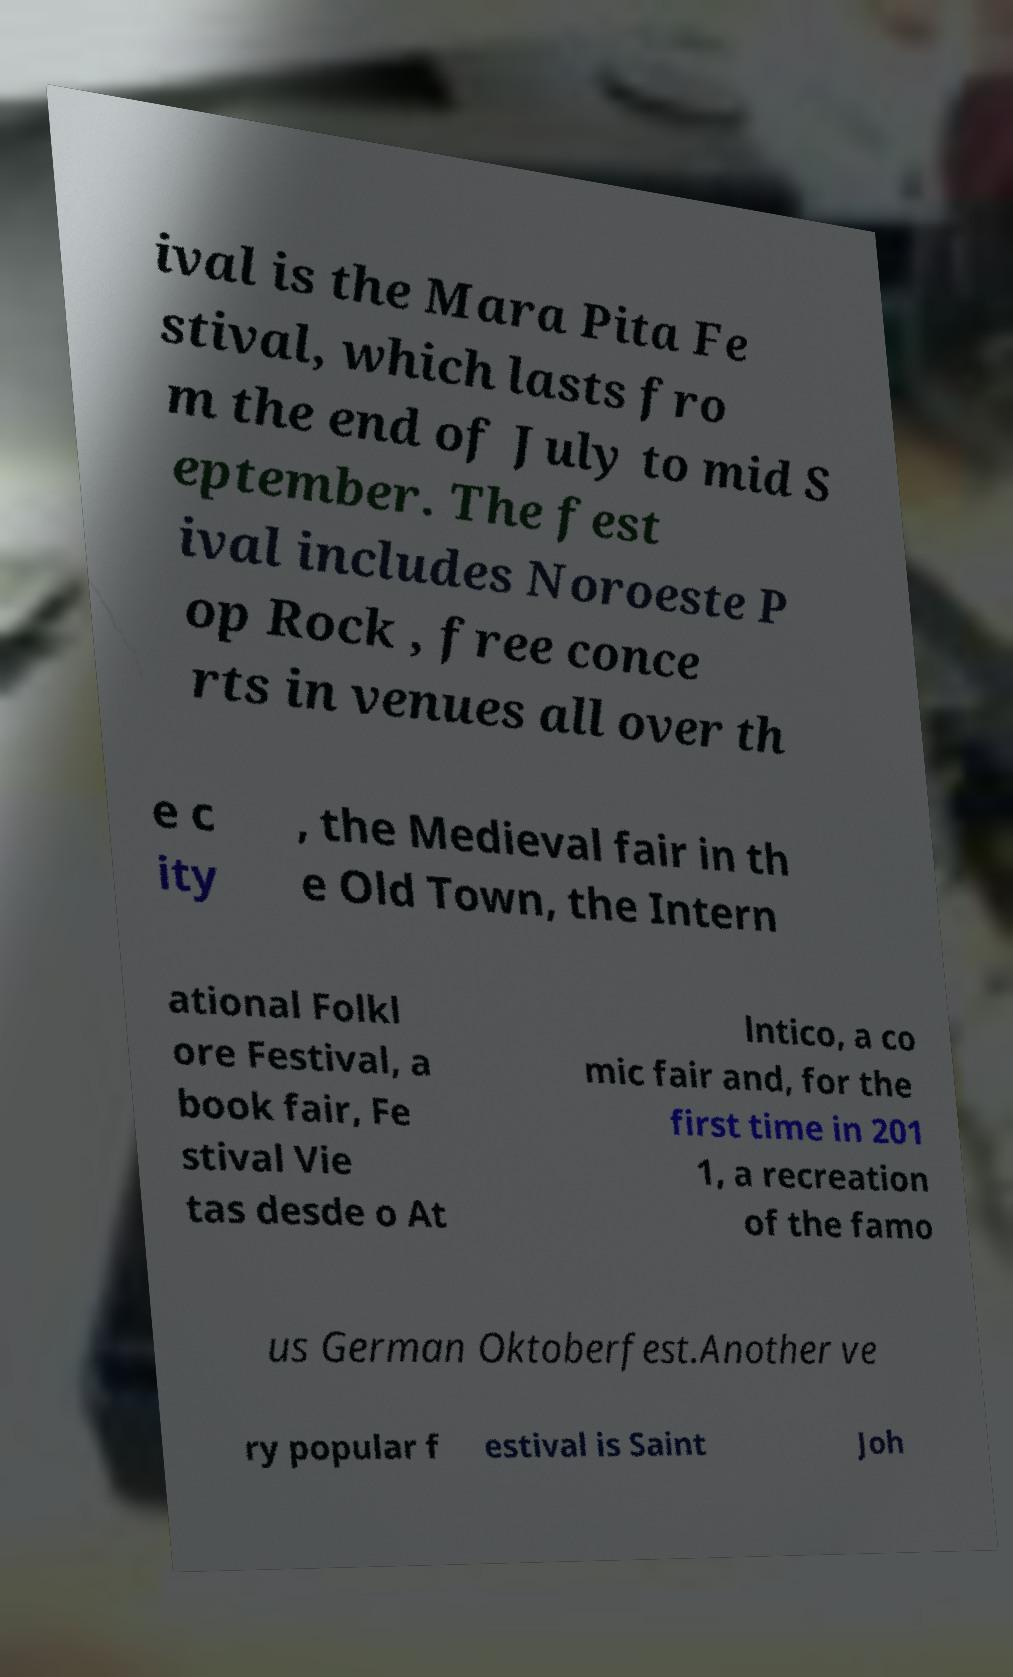There's text embedded in this image that I need extracted. Can you transcribe it verbatim? ival is the Mara Pita Fe stival, which lasts fro m the end of July to mid S eptember. The fest ival includes Noroeste P op Rock , free conce rts in venues all over th e c ity , the Medieval fair in th e Old Town, the Intern ational Folkl ore Festival, a book fair, Fe stival Vie tas desde o At lntico, a co mic fair and, for the first time in 201 1, a recreation of the famo us German Oktoberfest.Another ve ry popular f estival is Saint Joh 